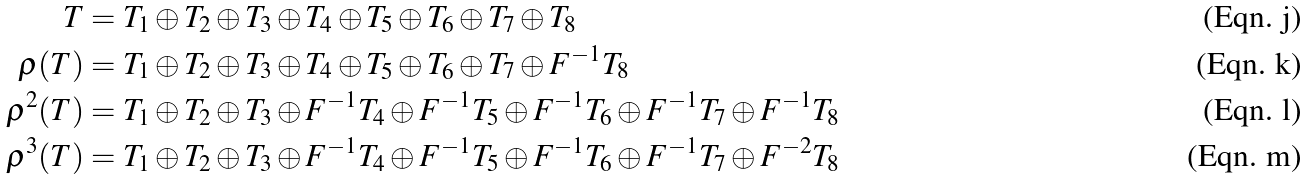Convert formula to latex. <formula><loc_0><loc_0><loc_500><loc_500>T & = T _ { 1 } \oplus T _ { 2 } \oplus T _ { 3 } \oplus T _ { 4 } \oplus T _ { 5 } \oplus T _ { 6 } \oplus T _ { 7 } \oplus T _ { 8 } \\ \rho ( T ) & = T _ { 1 } \oplus T _ { 2 } \oplus T _ { 3 } \oplus T _ { 4 } \oplus T _ { 5 } \oplus T _ { 6 } \oplus T _ { 7 } \oplus F ^ { - 1 } T _ { 8 } \\ \rho ^ { 2 } ( T ) & = T _ { 1 } \oplus T _ { 2 } \oplus T _ { 3 } \oplus F ^ { - 1 } T _ { 4 } \oplus F ^ { - 1 } T _ { 5 } \oplus F ^ { - 1 } T _ { 6 } \oplus F ^ { - 1 } T _ { 7 } \oplus F ^ { - 1 } T _ { 8 } \\ \rho ^ { 3 } ( T ) & = T _ { 1 } \oplus T _ { 2 } \oplus T _ { 3 } \oplus F ^ { - 1 } T _ { 4 } \oplus F ^ { - 1 } T _ { 5 } \oplus F ^ { - 1 } T _ { 6 } \oplus F ^ { - 1 } T _ { 7 } \oplus F ^ { - 2 } T _ { 8 }</formula> 